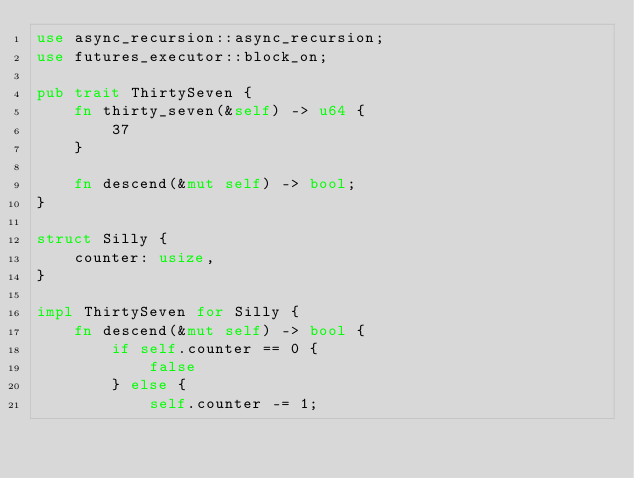Convert code to text. <code><loc_0><loc_0><loc_500><loc_500><_Rust_>use async_recursion::async_recursion;
use futures_executor::block_on;

pub trait ThirtySeven {
    fn thirty_seven(&self) -> u64 {
        37
    }

    fn descend(&mut self) -> bool;
}

struct Silly {
    counter: usize,
}

impl ThirtySeven for Silly {
    fn descend(&mut self) -> bool {
        if self.counter == 0 {
            false
        } else {
            self.counter -= 1;</code> 